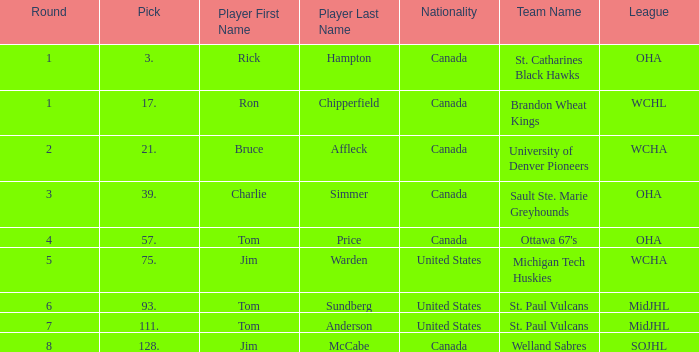Can you tell me the College/Junior/Club Team that has the Round of 4? Ottawa 67's (OHA). 